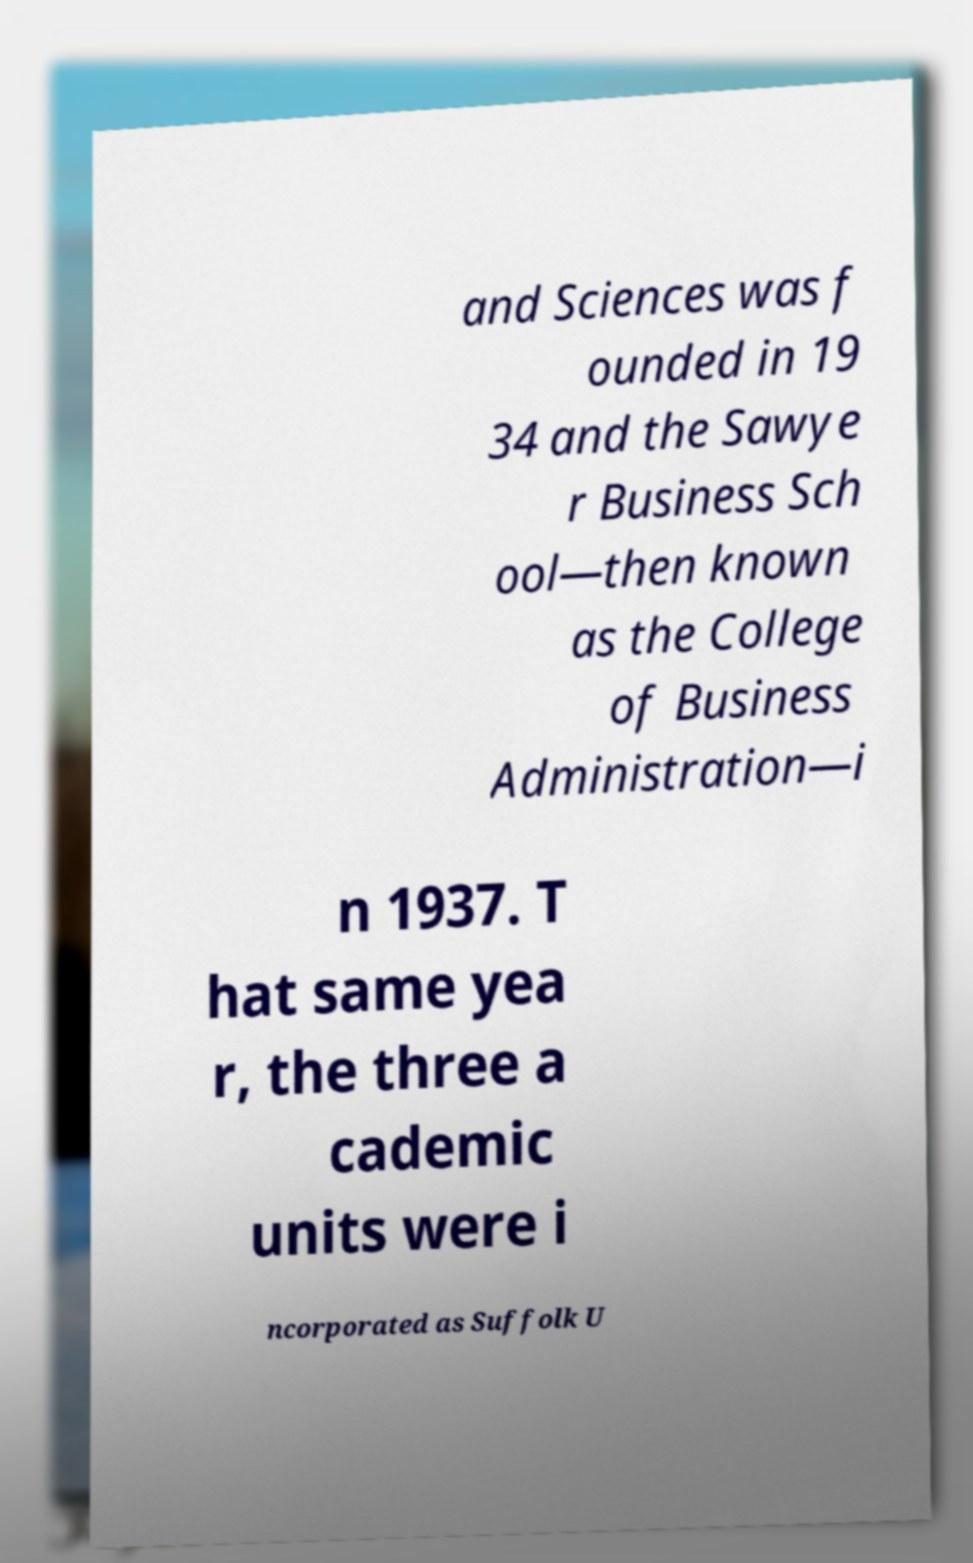Could you assist in decoding the text presented in this image and type it out clearly? and Sciences was f ounded in 19 34 and the Sawye r Business Sch ool—then known as the College of Business Administration—i n 1937. T hat same yea r, the three a cademic units were i ncorporated as Suffolk U 